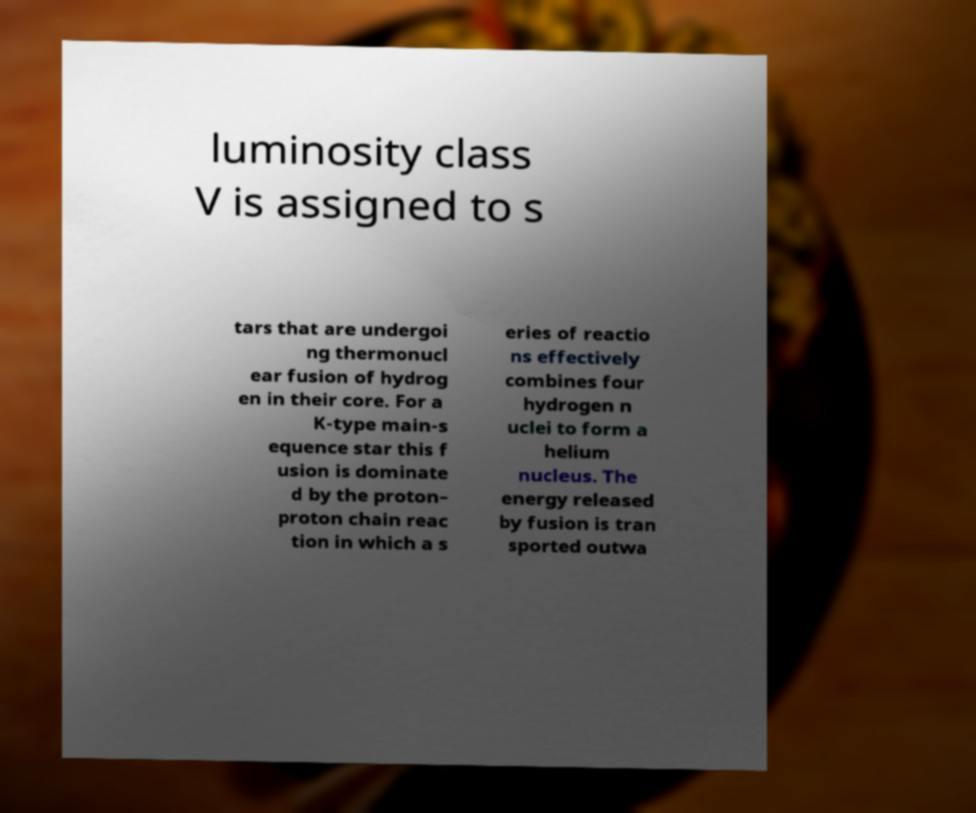Can you read and provide the text displayed in the image?This photo seems to have some interesting text. Can you extract and type it out for me? luminosity class V is assigned to s tars that are undergoi ng thermonucl ear fusion of hydrog en in their core. For a K-type main-s equence star this f usion is dominate d by the proton– proton chain reac tion in which a s eries of reactio ns effectively combines four hydrogen n uclei to form a helium nucleus. The energy released by fusion is tran sported outwa 